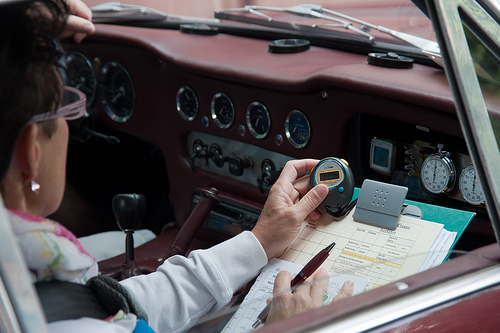Please provide a short description for this region: [0.58, 0.49, 0.96, 0.72]. This area shows a two-toned clipboard, green and grey, likely used for keeping records or documents, held by a person sitting in the vehicle. 